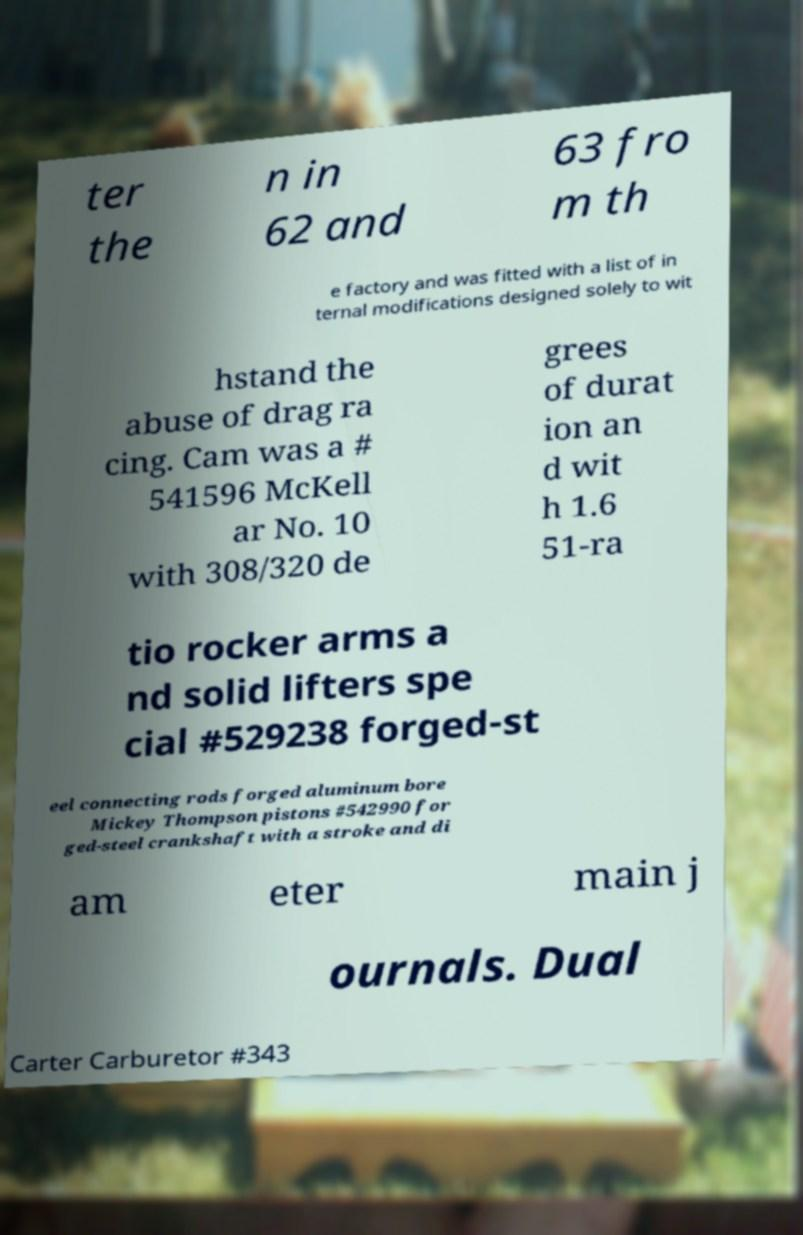Please identify and transcribe the text found in this image. ter the n in 62 and 63 fro m th e factory and was fitted with a list of in ternal modifications designed solely to wit hstand the abuse of drag ra cing. Cam was a # 541596 McKell ar No. 10 with 308/320 de grees of durat ion an d wit h 1.6 51-ra tio rocker arms a nd solid lifters spe cial #529238 forged-st eel connecting rods forged aluminum bore Mickey Thompson pistons #542990 for ged-steel crankshaft with a stroke and di am eter main j ournals. Dual Carter Carburetor #343 